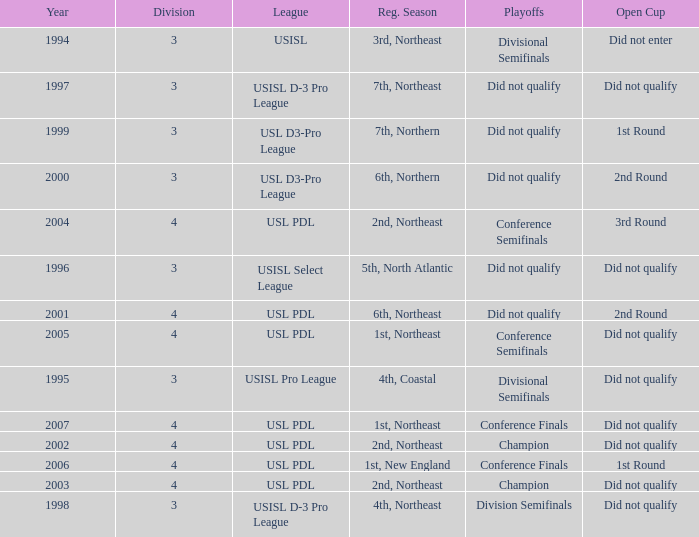Mame the reg season for 2001 6th, Northeast. 